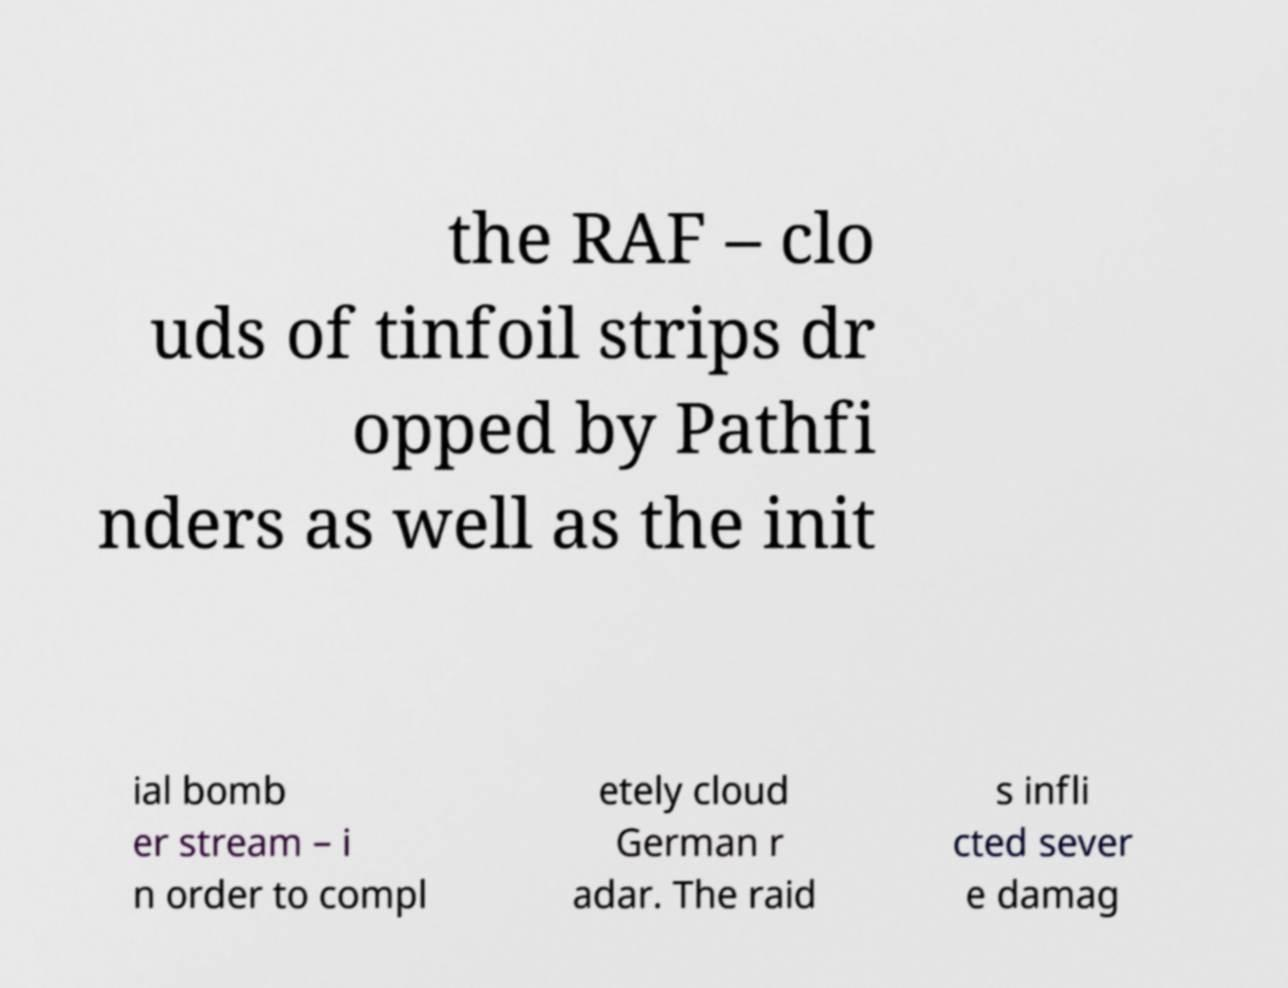Could you extract and type out the text from this image? the RAF – clo uds of tinfoil strips dr opped by Pathfi nders as well as the init ial bomb er stream – i n order to compl etely cloud German r adar. The raid s infli cted sever e damag 